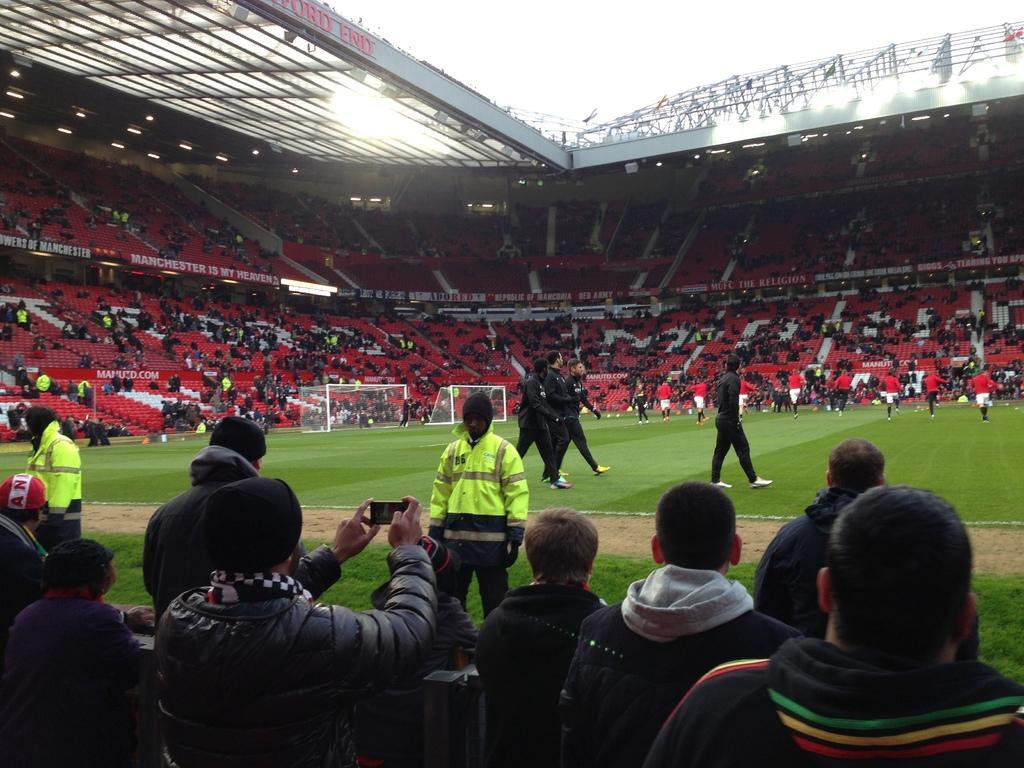Describe this image in one or two sentences. This is a stadium. At the bottom there are few people facing towards the back side. One person is holding a mobile in the hand. In the middle of the image, I can see many persons walking and running on the ground. In the background, I can see a crowd of people sitting in the stadium facing towards the ground. At the top there is a ceiling which is made up of metal. At the top of the image I can see the sky. 